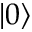<formula> <loc_0><loc_0><loc_500><loc_500>| 0 \rangle</formula> 